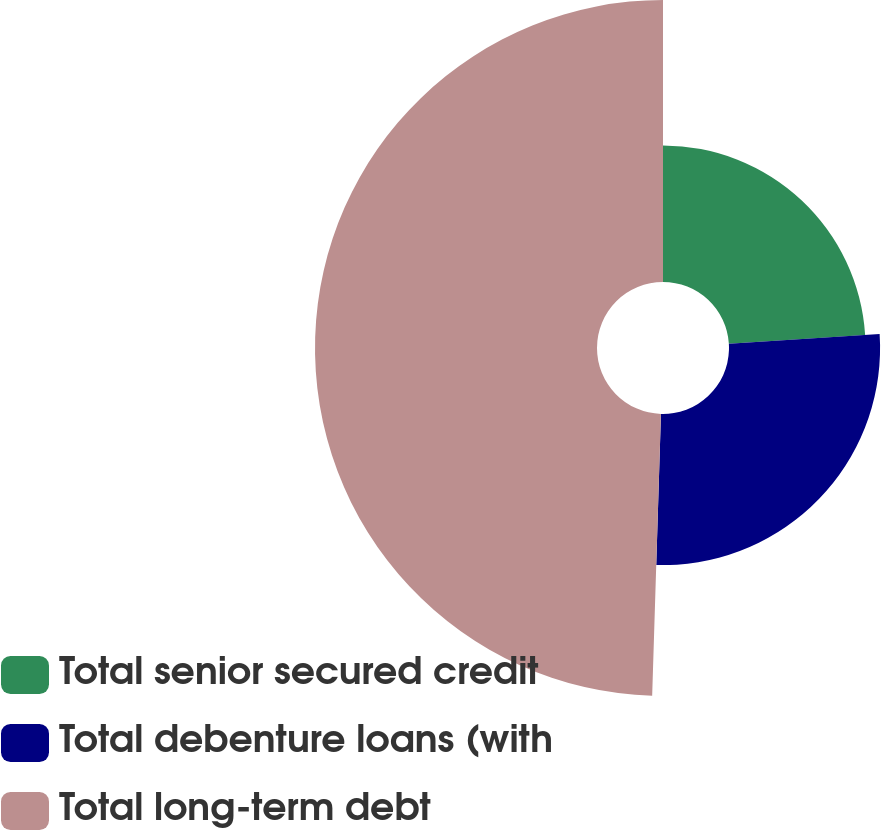Convert chart to OTSL. <chart><loc_0><loc_0><loc_500><loc_500><pie_chart><fcel>Total senior secured credit<fcel>Total debenture loans (with<fcel>Total long-term debt<nl><fcel>23.97%<fcel>26.52%<fcel>49.5%<nl></chart> 